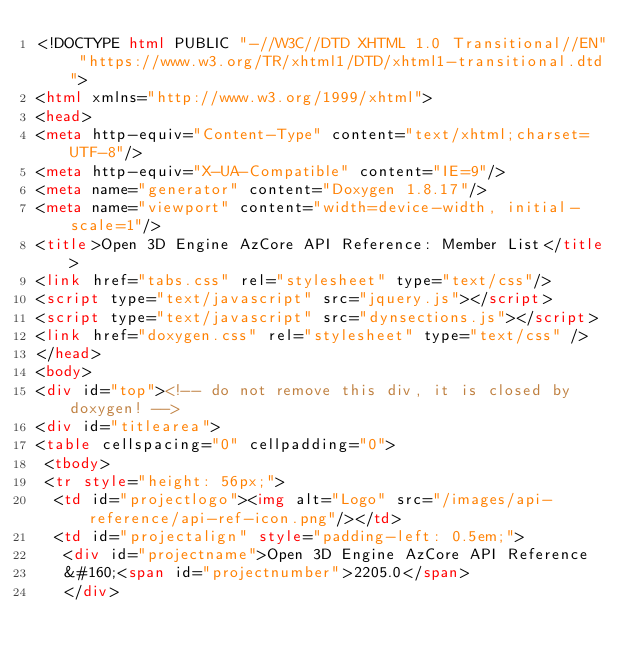<code> <loc_0><loc_0><loc_500><loc_500><_HTML_><!DOCTYPE html PUBLIC "-//W3C//DTD XHTML 1.0 Transitional//EN" "https://www.w3.org/TR/xhtml1/DTD/xhtml1-transitional.dtd">
<html xmlns="http://www.w3.org/1999/xhtml">
<head>
<meta http-equiv="Content-Type" content="text/xhtml;charset=UTF-8"/>
<meta http-equiv="X-UA-Compatible" content="IE=9"/>
<meta name="generator" content="Doxygen 1.8.17"/>
<meta name="viewport" content="width=device-width, initial-scale=1"/>
<title>Open 3D Engine AzCore API Reference: Member List</title>
<link href="tabs.css" rel="stylesheet" type="text/css"/>
<script type="text/javascript" src="jquery.js"></script>
<script type="text/javascript" src="dynsections.js"></script>
<link href="doxygen.css" rel="stylesheet" type="text/css" />
</head>
<body>
<div id="top"><!-- do not remove this div, it is closed by doxygen! -->
<div id="titlearea">
<table cellspacing="0" cellpadding="0">
 <tbody>
 <tr style="height: 56px;">
  <td id="projectlogo"><img alt="Logo" src="/images/api-reference/api-ref-icon.png"/></td>
  <td id="projectalign" style="padding-left: 0.5em;">
   <div id="projectname">Open 3D Engine AzCore API Reference
   &#160;<span id="projectnumber">2205.0</span>
   </div></code> 